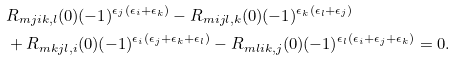Convert formula to latex. <formula><loc_0><loc_0><loc_500><loc_500>& R _ { m j i k , l } ( 0 ) ( - 1 ) ^ { \epsilon _ { j } ( \epsilon _ { i } + \epsilon _ { k } ) } - R _ { m i j l , k } ( 0 ) ( - 1 ) ^ { \epsilon _ { k } ( \epsilon _ { l } + \epsilon _ { j } ) } \\ & + R _ { m k j l , i } ( 0 ) ( - 1 ) ^ { \epsilon _ { i } ( \epsilon _ { j } + \epsilon _ { k } + \epsilon _ { l } ) } - R _ { m l i k , j } ( 0 ) ( - 1 ) ^ { \epsilon _ { l } ( \epsilon _ { i } + \epsilon _ { j } + \epsilon _ { k } ) } = 0 .</formula> 